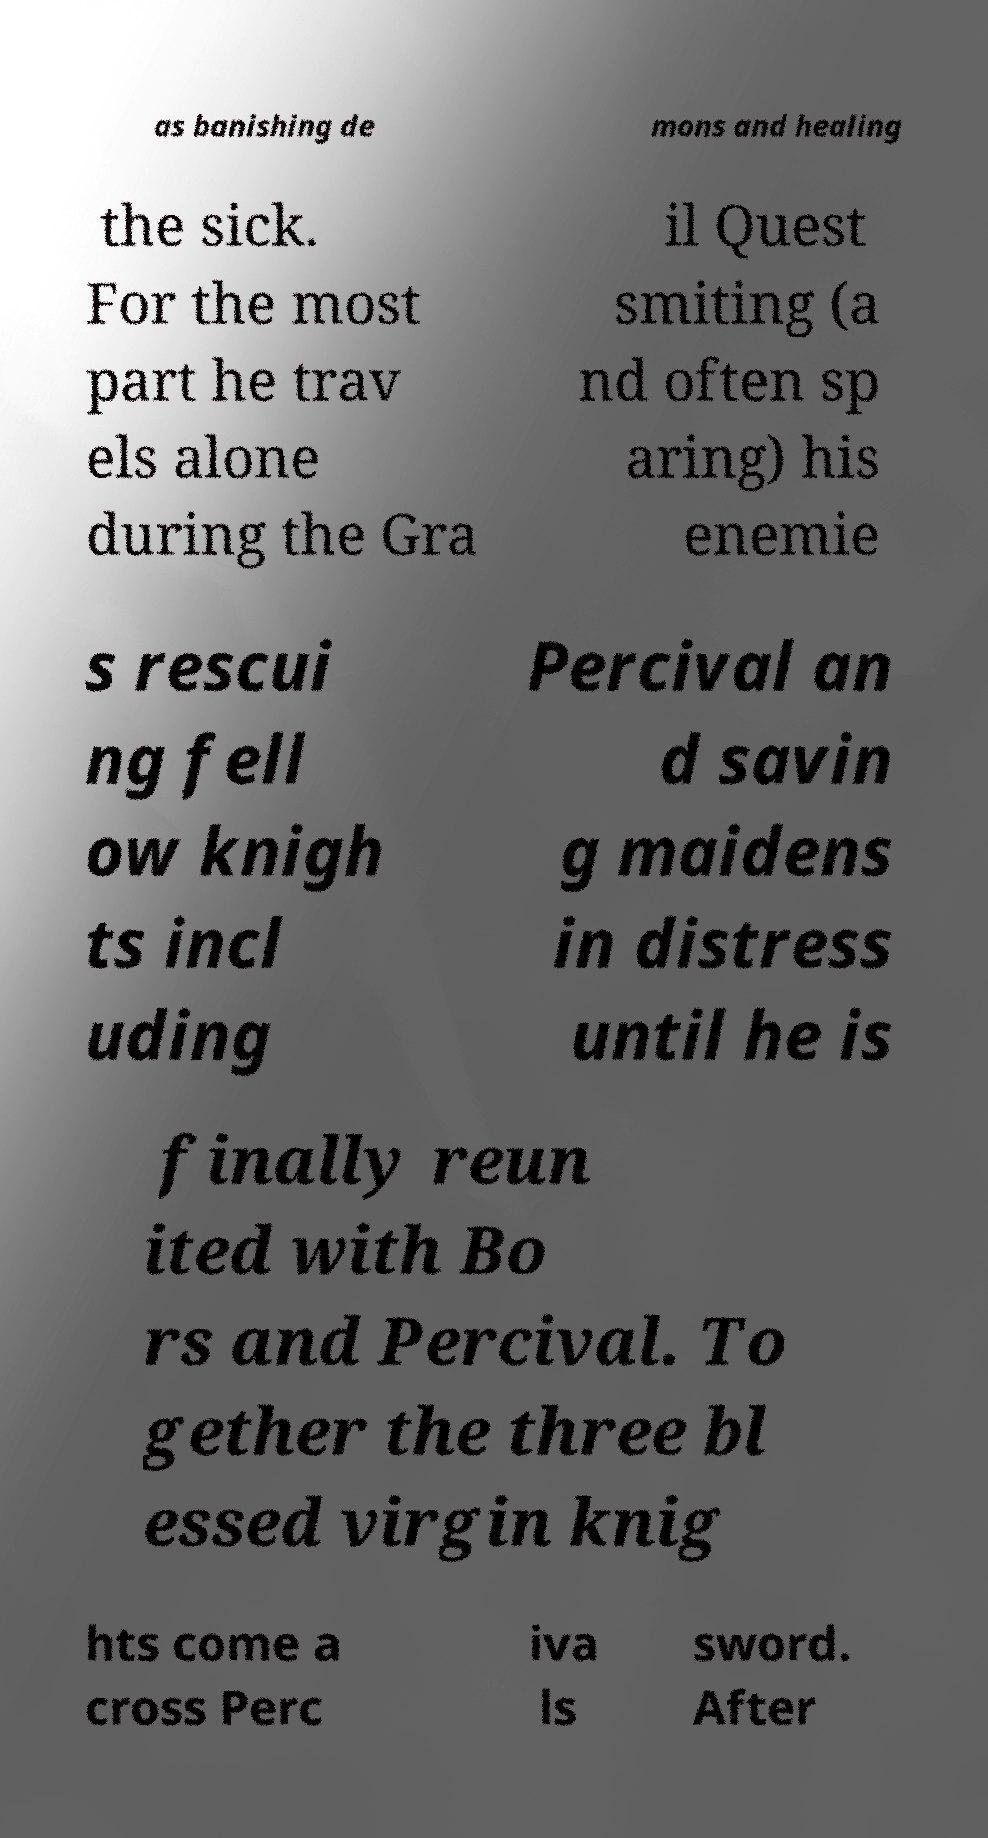Can you read and provide the text displayed in the image?This photo seems to have some interesting text. Can you extract and type it out for me? as banishing de mons and healing the sick. For the most part he trav els alone during the Gra il Quest smiting (a nd often sp aring) his enemie s rescui ng fell ow knigh ts incl uding Percival an d savin g maidens in distress until he is finally reun ited with Bo rs and Percival. To gether the three bl essed virgin knig hts come a cross Perc iva ls sword. After 